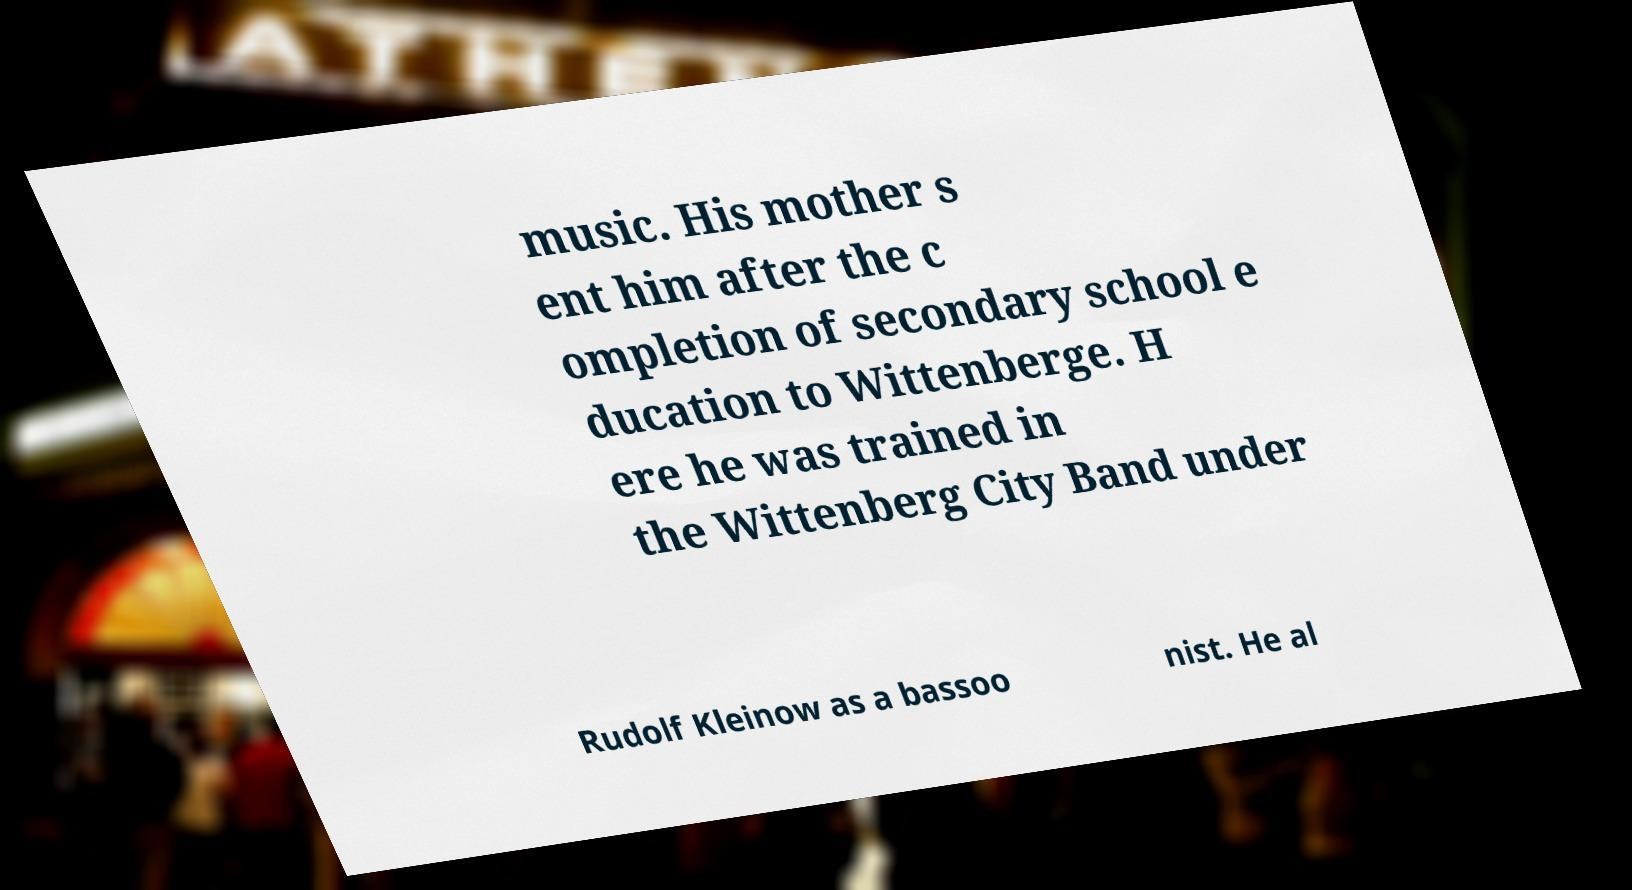Please identify and transcribe the text found in this image. music. His mother s ent him after the c ompletion of secondary school e ducation to Wittenberge. H ere he was trained in the Wittenberg City Band under Rudolf Kleinow as a bassoo nist. He al 